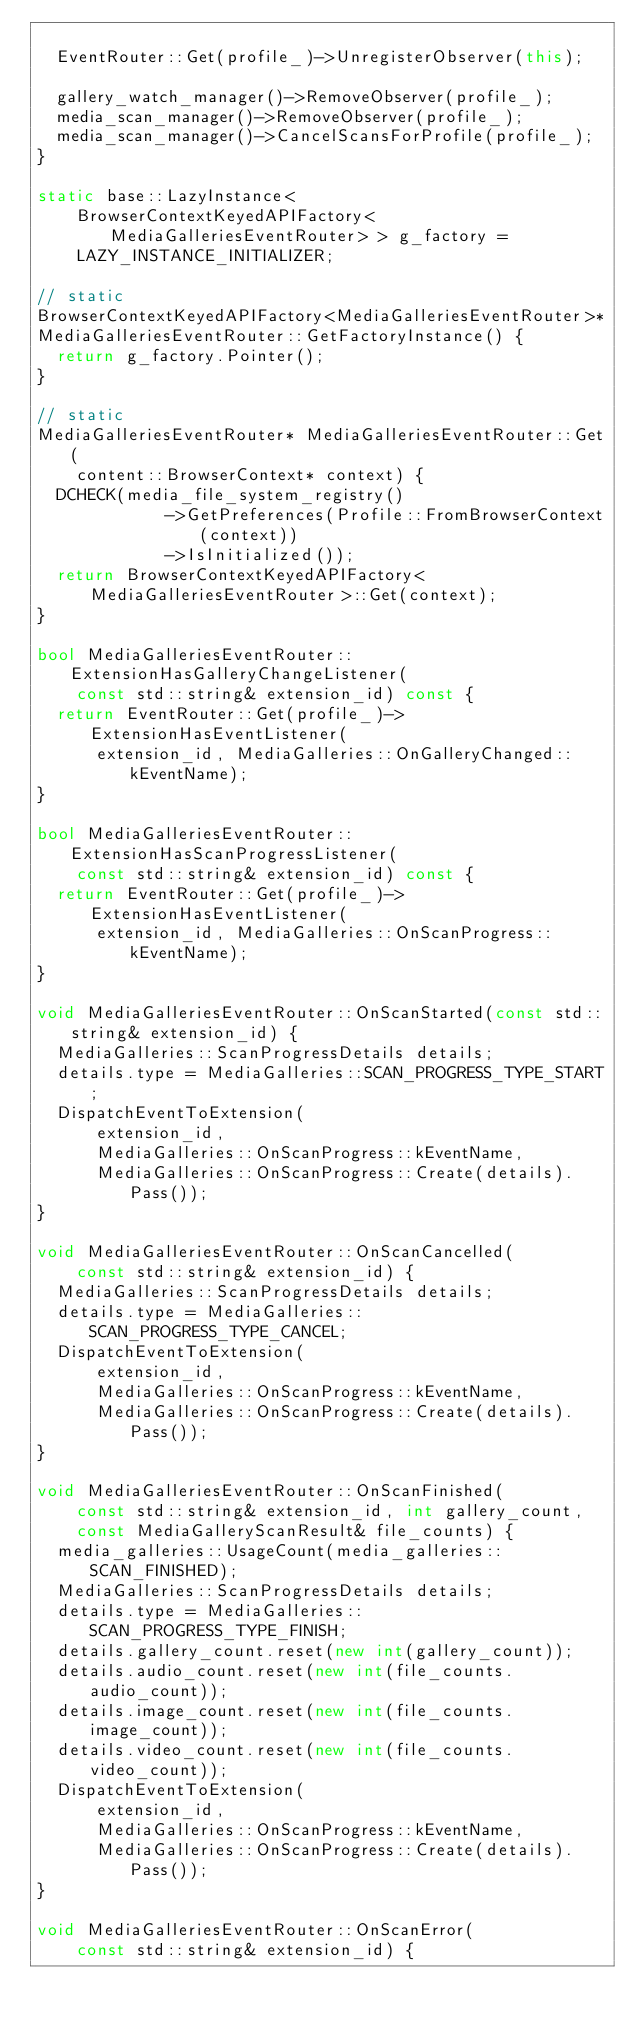<code> <loc_0><loc_0><loc_500><loc_500><_C++_>
  EventRouter::Get(profile_)->UnregisterObserver(this);

  gallery_watch_manager()->RemoveObserver(profile_);
  media_scan_manager()->RemoveObserver(profile_);
  media_scan_manager()->CancelScansForProfile(profile_);
}

static base::LazyInstance<
    BrowserContextKeyedAPIFactory<MediaGalleriesEventRouter> > g_factory =
    LAZY_INSTANCE_INITIALIZER;

// static
BrowserContextKeyedAPIFactory<MediaGalleriesEventRouter>*
MediaGalleriesEventRouter::GetFactoryInstance() {
  return g_factory.Pointer();
}

// static
MediaGalleriesEventRouter* MediaGalleriesEventRouter::Get(
    content::BrowserContext* context) {
  DCHECK(media_file_system_registry()
             ->GetPreferences(Profile::FromBrowserContext(context))
             ->IsInitialized());
  return BrowserContextKeyedAPIFactory<MediaGalleriesEventRouter>::Get(context);
}

bool MediaGalleriesEventRouter::ExtensionHasGalleryChangeListener(
    const std::string& extension_id) const {
  return EventRouter::Get(profile_)->ExtensionHasEventListener(
      extension_id, MediaGalleries::OnGalleryChanged::kEventName);
}

bool MediaGalleriesEventRouter::ExtensionHasScanProgressListener(
    const std::string& extension_id) const {
  return EventRouter::Get(profile_)->ExtensionHasEventListener(
      extension_id, MediaGalleries::OnScanProgress::kEventName);
}

void MediaGalleriesEventRouter::OnScanStarted(const std::string& extension_id) {
  MediaGalleries::ScanProgressDetails details;
  details.type = MediaGalleries::SCAN_PROGRESS_TYPE_START;
  DispatchEventToExtension(
      extension_id,
      MediaGalleries::OnScanProgress::kEventName,
      MediaGalleries::OnScanProgress::Create(details).Pass());
}

void MediaGalleriesEventRouter::OnScanCancelled(
    const std::string& extension_id) {
  MediaGalleries::ScanProgressDetails details;
  details.type = MediaGalleries::SCAN_PROGRESS_TYPE_CANCEL;
  DispatchEventToExtension(
      extension_id,
      MediaGalleries::OnScanProgress::kEventName,
      MediaGalleries::OnScanProgress::Create(details).Pass());
}

void MediaGalleriesEventRouter::OnScanFinished(
    const std::string& extension_id, int gallery_count,
    const MediaGalleryScanResult& file_counts) {
  media_galleries::UsageCount(media_galleries::SCAN_FINISHED);
  MediaGalleries::ScanProgressDetails details;
  details.type = MediaGalleries::SCAN_PROGRESS_TYPE_FINISH;
  details.gallery_count.reset(new int(gallery_count));
  details.audio_count.reset(new int(file_counts.audio_count));
  details.image_count.reset(new int(file_counts.image_count));
  details.video_count.reset(new int(file_counts.video_count));
  DispatchEventToExtension(
      extension_id,
      MediaGalleries::OnScanProgress::kEventName,
      MediaGalleries::OnScanProgress::Create(details).Pass());
}

void MediaGalleriesEventRouter::OnScanError(
    const std::string& extension_id) {</code> 